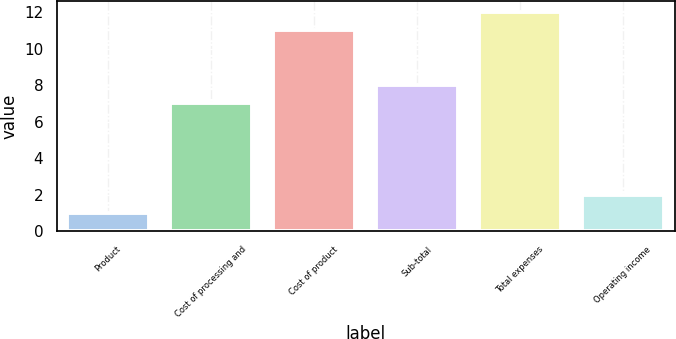<chart> <loc_0><loc_0><loc_500><loc_500><bar_chart><fcel>Product<fcel>Cost of processing and<fcel>Cost of product<fcel>Sub-total<fcel>Total expenses<fcel>Operating income<nl><fcel>1<fcel>7<fcel>11<fcel>8<fcel>12<fcel>2<nl></chart> 